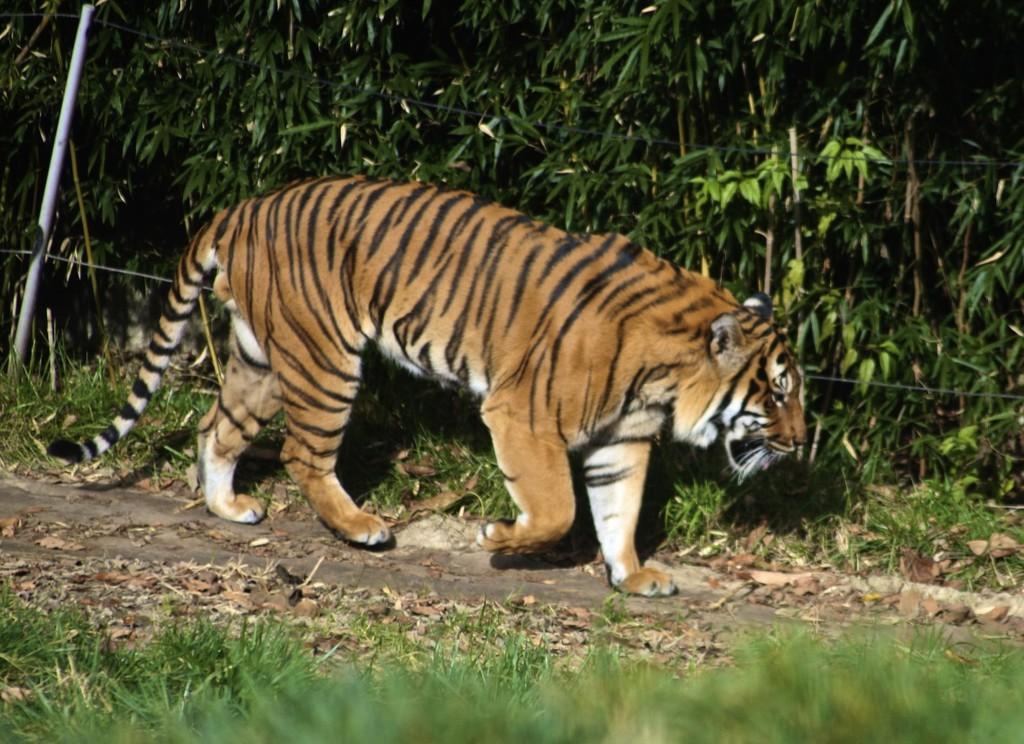Please provide a concise description of this image. In this image we can see a tiger, here is the tail, here are the trees, here is the grass, here are the dried twigs on the ground. 